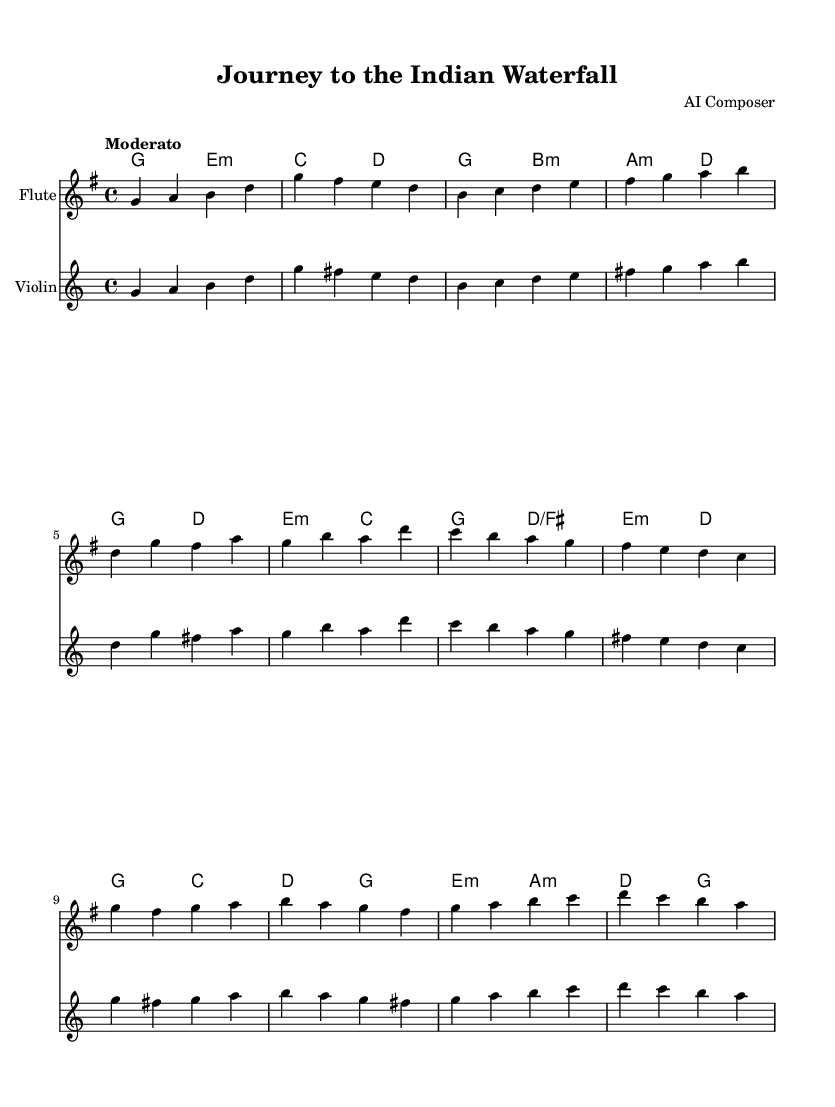What is the title of this piece? The title is specified in the header section of the sheet music as "Journey to the Indian Waterfall."
Answer: Journey to the Indian Waterfall What is the key signature of this music? The key signature is G major, which has one sharp (F#). This can be determined from the key indicated at the beginning of the score.
Answer: G major What is the time signature of this music? The time signature is 4/4, indicated at the beginning of the score. This means there are four beats per measure, and the quarter note receives one beat.
Answer: 4/4 What is the tempo marking of this piece? The tempo is marked as "Moderato," which suggests a moderate pace. This designation is found at the beginning of the score.
Answer: Moderato How many measures are there in the flute part? By counting each line and noting the measures in the flute part, there are 12 measures total in the flute section.
Answer: 12 Which instruments are included in this symphony? The orchestration includes two instruments: flute and violin, as indicated by their respective staffs in the score.
Answer: Flute and Violin What is the relationship between the flute and violin parts? The flute and violin parts are identical throughout the piece; they play the same melodic lines and rhythms, which is common in orchestral symphonies.
Answer: Identical 